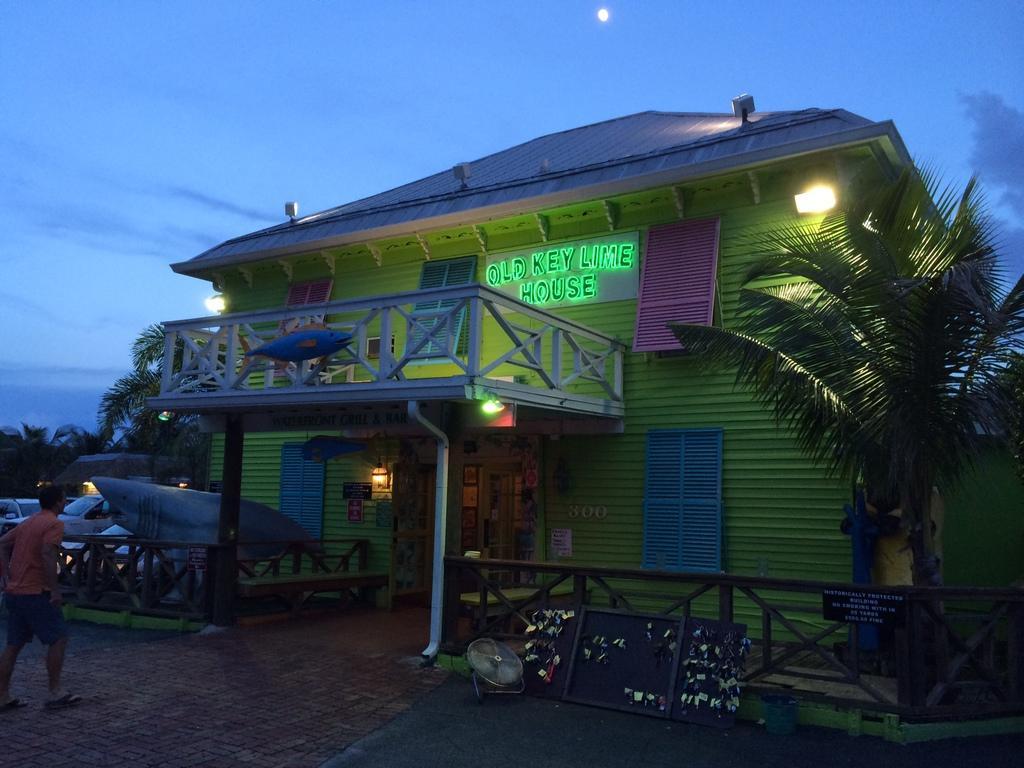Could you give a brief overview of what you see in this image? In this image, we can see a house with windows, railings, pillars, walls and lights. Here we can see some sticker and name boards. At the bottom, there is a walkway, some objects. Here we can see few trees, vehicles. Left side of the image, a person is walking. Background there is a sky and moon. 